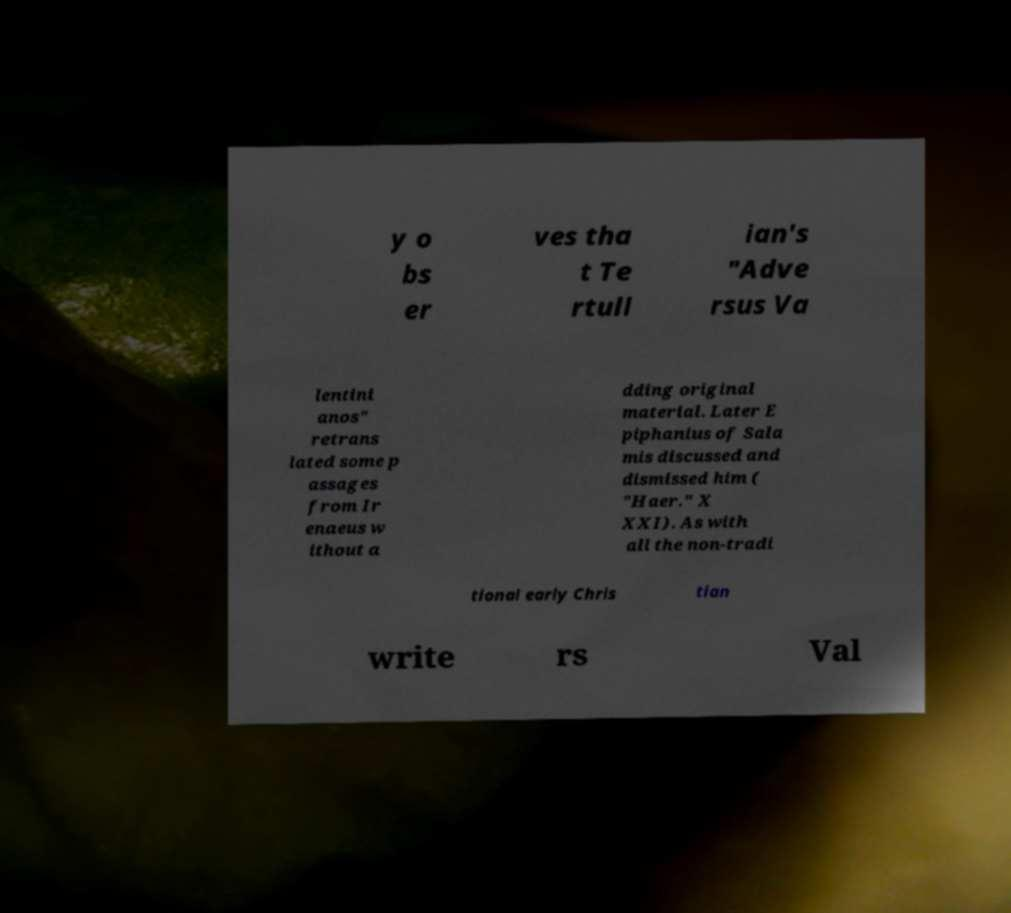There's text embedded in this image that I need extracted. Can you transcribe it verbatim? y o bs er ves tha t Te rtull ian's "Adve rsus Va lentini anos" retrans lated some p assages from Ir enaeus w ithout a dding original material. Later E piphanius of Sala mis discussed and dismissed him ( "Haer." X XXI). As with all the non-tradi tional early Chris tian write rs Val 